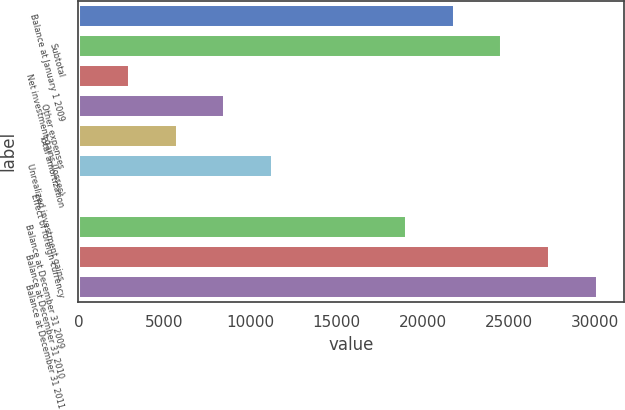Convert chart to OTSL. <chart><loc_0><loc_0><loc_500><loc_500><bar_chart><fcel>Balance at January 1 2009<fcel>Subtotal<fcel>Net investment gains (losses)<fcel>Other expenses<fcel>Total amortization<fcel>Unrealized investment gains<fcel>Effect of foreign currency<fcel>Balance at December 31 2009<fcel>Balance at December 31 2010<fcel>Balance at December 31 2011<nl><fcel>21858.7<fcel>24634.4<fcel>2989.7<fcel>8541.1<fcel>5765.4<fcel>11316.8<fcel>214<fcel>19083<fcel>27410.1<fcel>30185.8<nl></chart> 